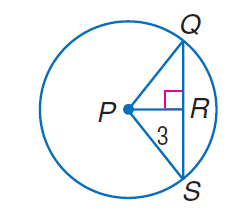Question: The radius of \odot P is 5 and P R = 3. Find Q S.
Choices:
A. 3
B. 5
C. 6
D. 8
Answer with the letter. Answer: D 